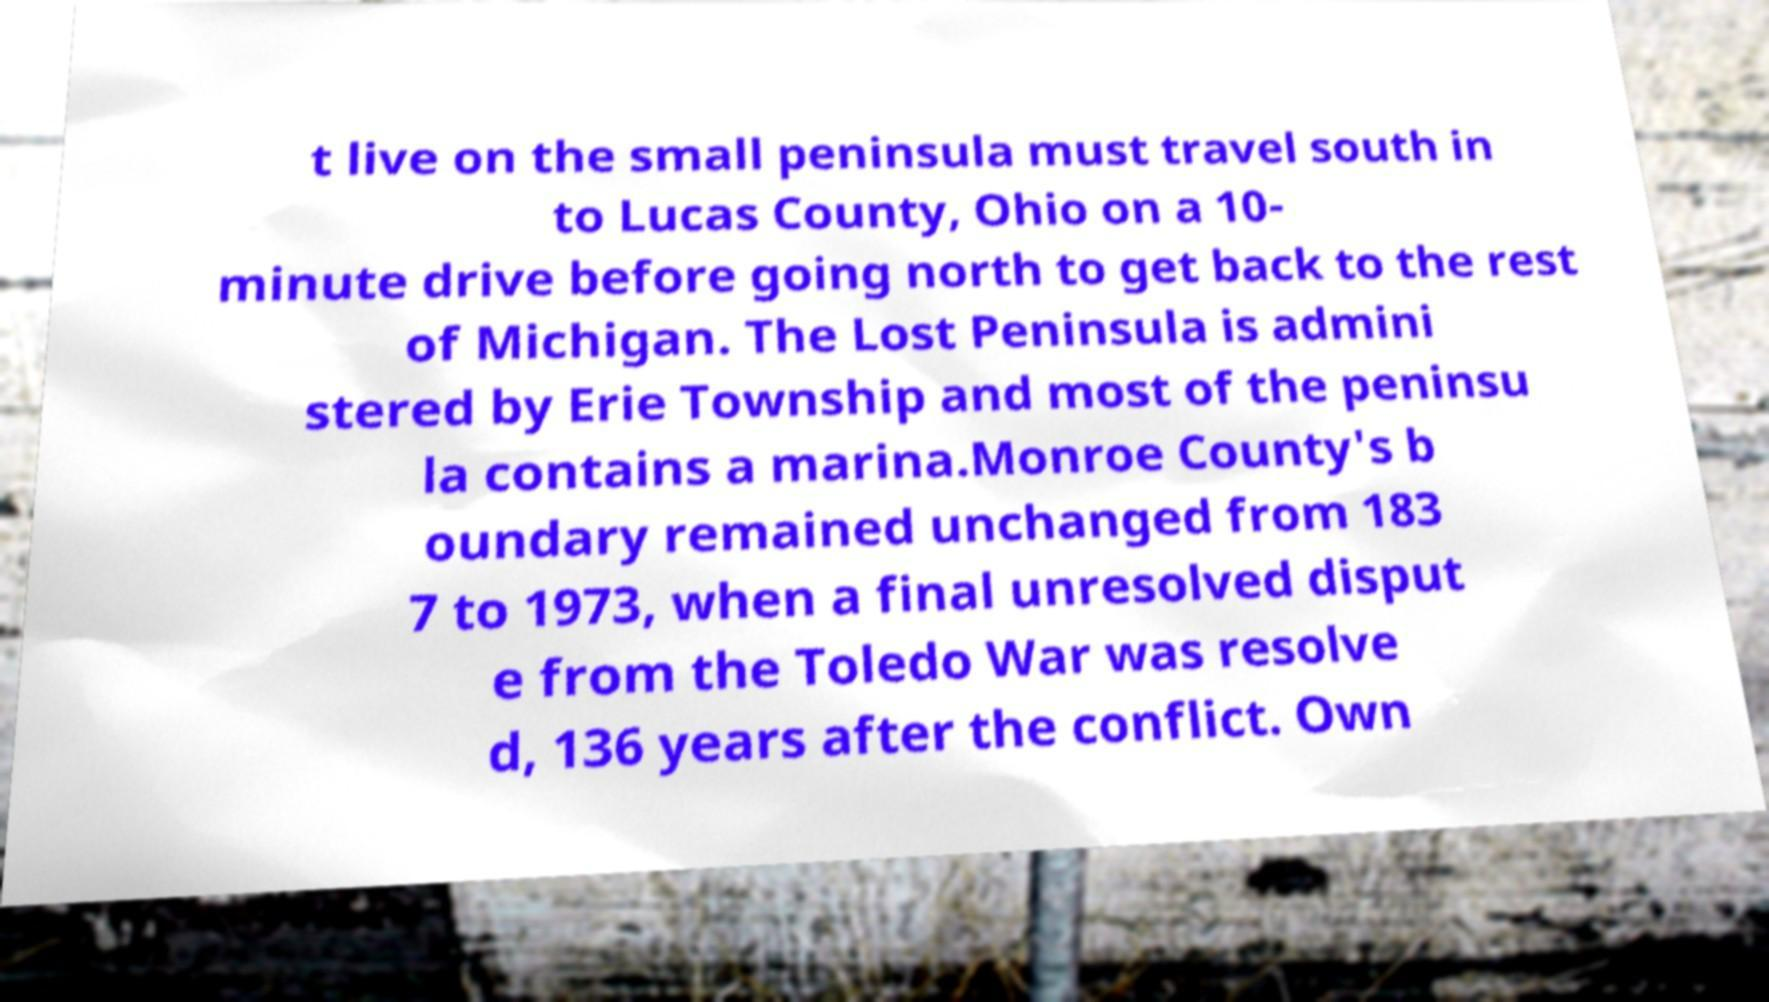For documentation purposes, I need the text within this image transcribed. Could you provide that? t live on the small peninsula must travel south in to Lucas County, Ohio on a 10- minute drive before going north to get back to the rest of Michigan. The Lost Peninsula is admini stered by Erie Township and most of the peninsu la contains a marina.Monroe County's b oundary remained unchanged from 183 7 to 1973, when a final unresolved disput e from the Toledo War was resolve d, 136 years after the conflict. Own 